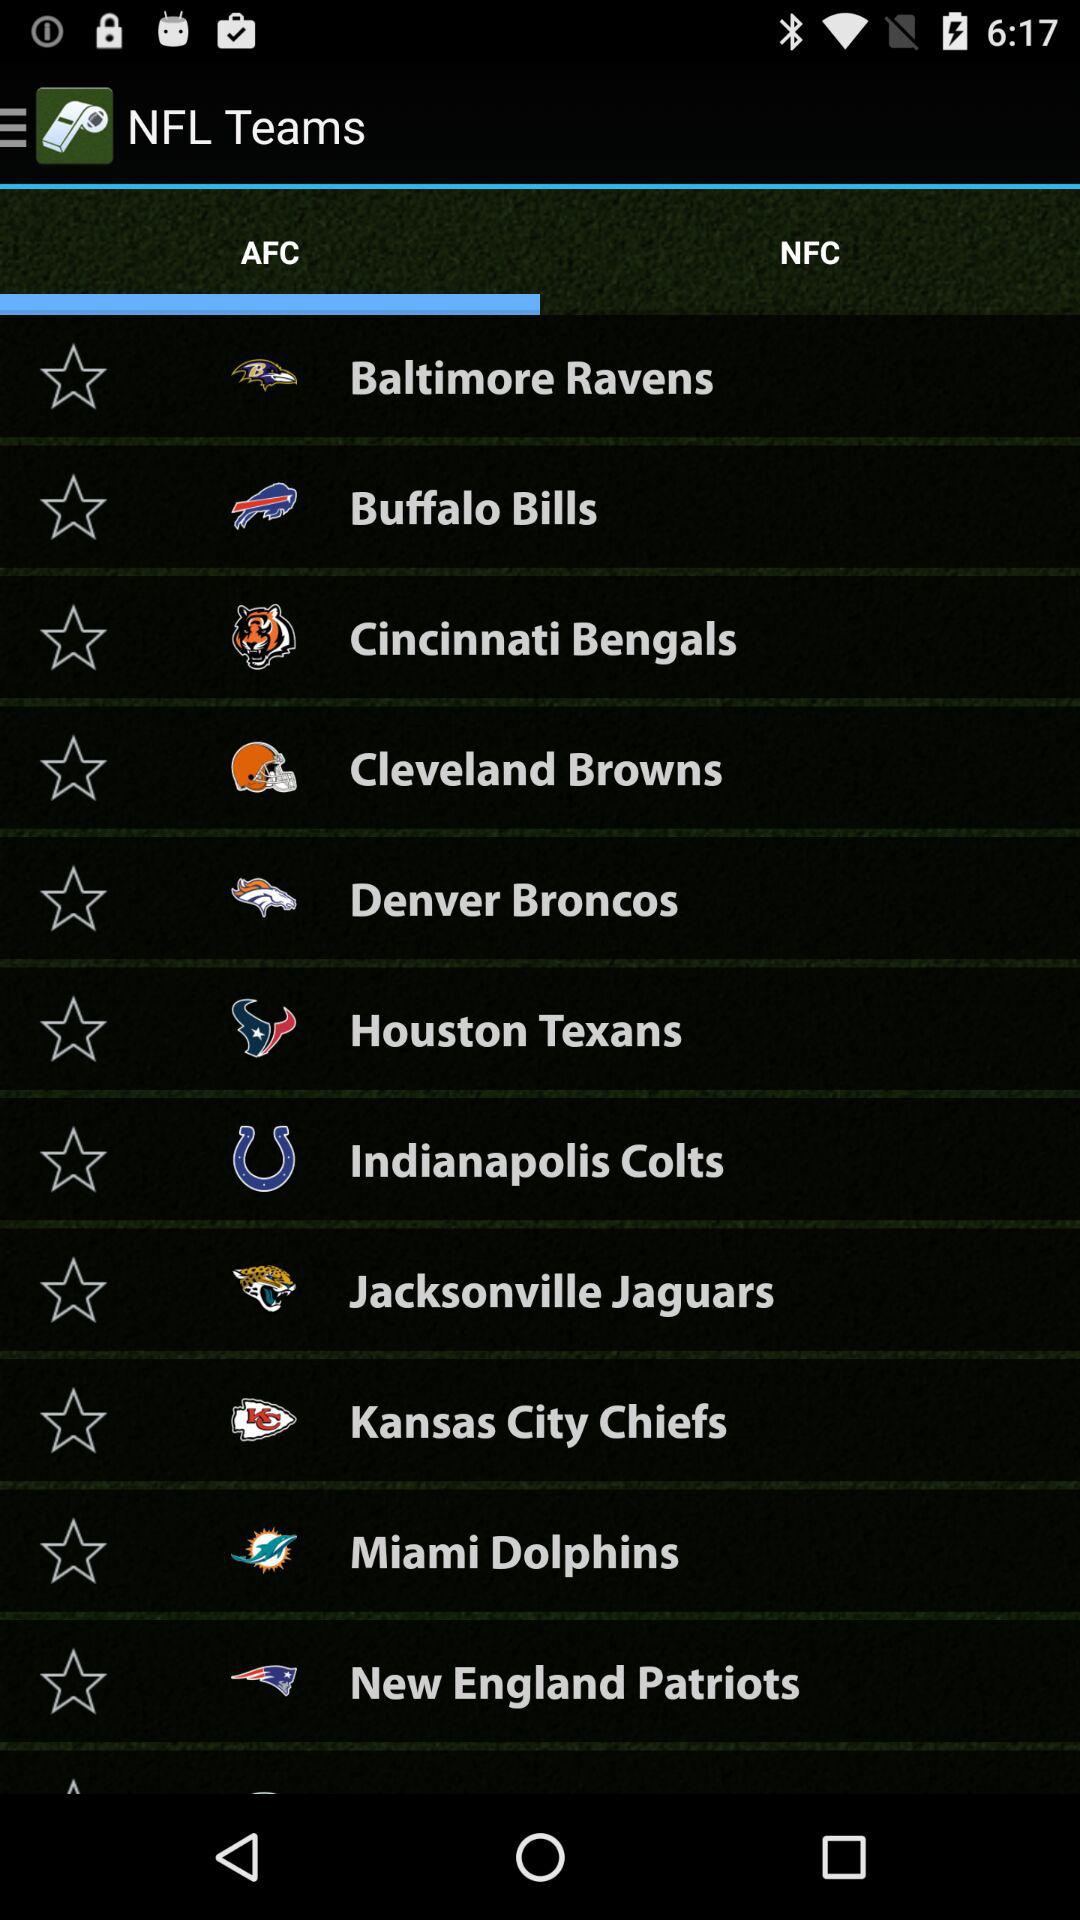Which tab has been selected? The selected tab is "AFC". 